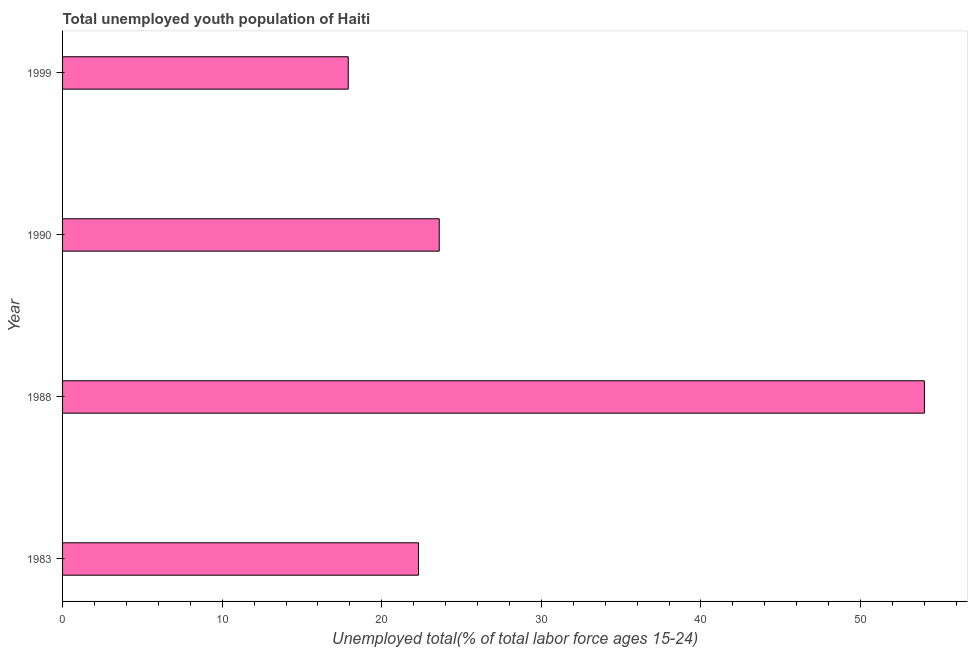What is the title of the graph?
Your answer should be compact. Total unemployed youth population of Haiti. What is the label or title of the X-axis?
Your answer should be compact. Unemployed total(% of total labor force ages 15-24). What is the unemployed youth in 1999?
Offer a very short reply. 17.9. Across all years, what is the minimum unemployed youth?
Provide a succinct answer. 17.9. In which year was the unemployed youth maximum?
Make the answer very short. 1988. In which year was the unemployed youth minimum?
Offer a very short reply. 1999. What is the sum of the unemployed youth?
Your response must be concise. 117.8. What is the difference between the unemployed youth in 1988 and 1990?
Ensure brevity in your answer.  30.4. What is the average unemployed youth per year?
Make the answer very short. 29.45. What is the median unemployed youth?
Keep it short and to the point. 22.95. In how many years, is the unemployed youth greater than 4 %?
Provide a short and direct response. 4. What is the ratio of the unemployed youth in 1988 to that in 1999?
Provide a succinct answer. 3.02. Is the unemployed youth in 1983 less than that in 1990?
Your answer should be very brief. Yes. What is the difference between the highest and the second highest unemployed youth?
Your answer should be compact. 30.4. What is the difference between the highest and the lowest unemployed youth?
Your answer should be compact. 36.1. How many bars are there?
Make the answer very short. 4. Are all the bars in the graph horizontal?
Provide a short and direct response. Yes. What is the difference between two consecutive major ticks on the X-axis?
Keep it short and to the point. 10. Are the values on the major ticks of X-axis written in scientific E-notation?
Provide a short and direct response. No. What is the Unemployed total(% of total labor force ages 15-24) in 1983?
Give a very brief answer. 22.3. What is the Unemployed total(% of total labor force ages 15-24) in 1990?
Offer a very short reply. 23.6. What is the Unemployed total(% of total labor force ages 15-24) in 1999?
Give a very brief answer. 17.9. What is the difference between the Unemployed total(% of total labor force ages 15-24) in 1983 and 1988?
Provide a short and direct response. -31.7. What is the difference between the Unemployed total(% of total labor force ages 15-24) in 1983 and 1990?
Make the answer very short. -1.3. What is the difference between the Unemployed total(% of total labor force ages 15-24) in 1983 and 1999?
Offer a terse response. 4.4. What is the difference between the Unemployed total(% of total labor force ages 15-24) in 1988 and 1990?
Ensure brevity in your answer.  30.4. What is the difference between the Unemployed total(% of total labor force ages 15-24) in 1988 and 1999?
Your answer should be compact. 36.1. What is the ratio of the Unemployed total(% of total labor force ages 15-24) in 1983 to that in 1988?
Your answer should be compact. 0.41. What is the ratio of the Unemployed total(% of total labor force ages 15-24) in 1983 to that in 1990?
Offer a terse response. 0.94. What is the ratio of the Unemployed total(% of total labor force ages 15-24) in 1983 to that in 1999?
Provide a succinct answer. 1.25. What is the ratio of the Unemployed total(% of total labor force ages 15-24) in 1988 to that in 1990?
Provide a succinct answer. 2.29. What is the ratio of the Unemployed total(% of total labor force ages 15-24) in 1988 to that in 1999?
Your response must be concise. 3.02. What is the ratio of the Unemployed total(% of total labor force ages 15-24) in 1990 to that in 1999?
Give a very brief answer. 1.32. 